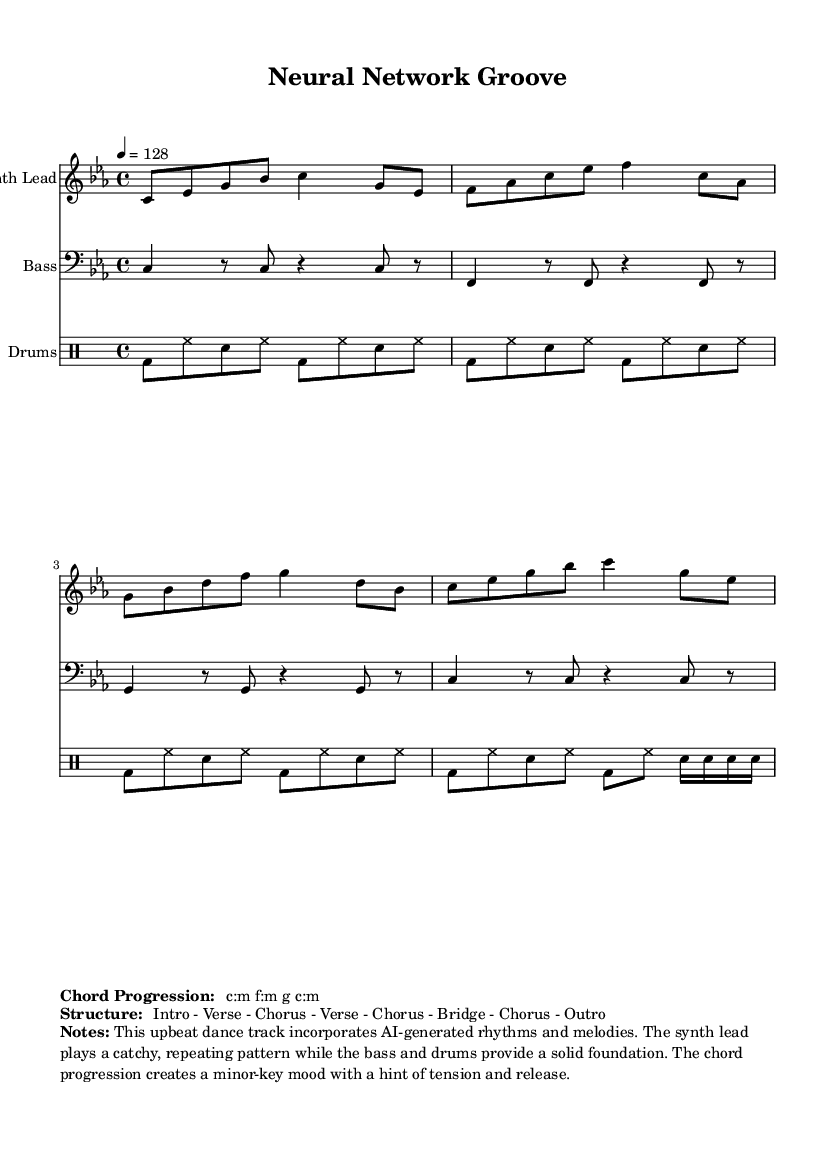What is the key signature of this music? The key signature is C minor, which has three flats (B♭, E♭, A♭). This can be identified in the key signature section at the beginning of the score.
Answer: C minor What is the time signature of the piece? The time signature indicated on the score is 4/4, which is standard for dance music, allowing for four beats per measure. This is shown at the beginning of the score following the key signature.
Answer: 4/4 What is the tempo marking for this piece? The tempo marking indicates a speed of 128 BPM (beats per minute), which is typical for upbeat dance tracks. It is specified in the tempo section at the start of the score.
Answer: 128 What is the chord progression used in the track? The chord progression listed is C minor, F minor, G, C minor. This is presented in the "Chord Progression" markup section.
Answer: C:m f:m g c:m How many sections does the structure of the piece have? The structure consists of eight sections: Intro, Verse, Chorus, Verse, Chorus, Bridge, Chorus, Outro. The number of sections is counted from the "Structure" markup section.
Answer: Eight What type of instrumentation is featured in this score? The instrumentation includes Synth Lead, Bass, and Drums. This is evident in the score where each part is assigned to a specific staff labeled accordingly.
Answer: Synth Lead, Bass, Drums What style of rhythms does the drum section incorporate? The drum section includes a pattern with bass drum, hi-hat, and snare, typical for energetic dance music. The rhythm is characterized by consistent eighth notes and syncopated accents, which is specified in the drummode section.
Answer: Eighth notes with accents 